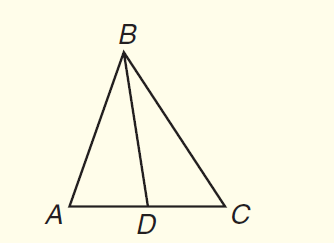Question: In \triangle A B C, B D is a median. If A D = 3 x + 5 and C D = 5 x - 1, find A C.
Choices:
A. 3
B. 11
C. 14
D. 28
Answer with the letter. Answer: D 